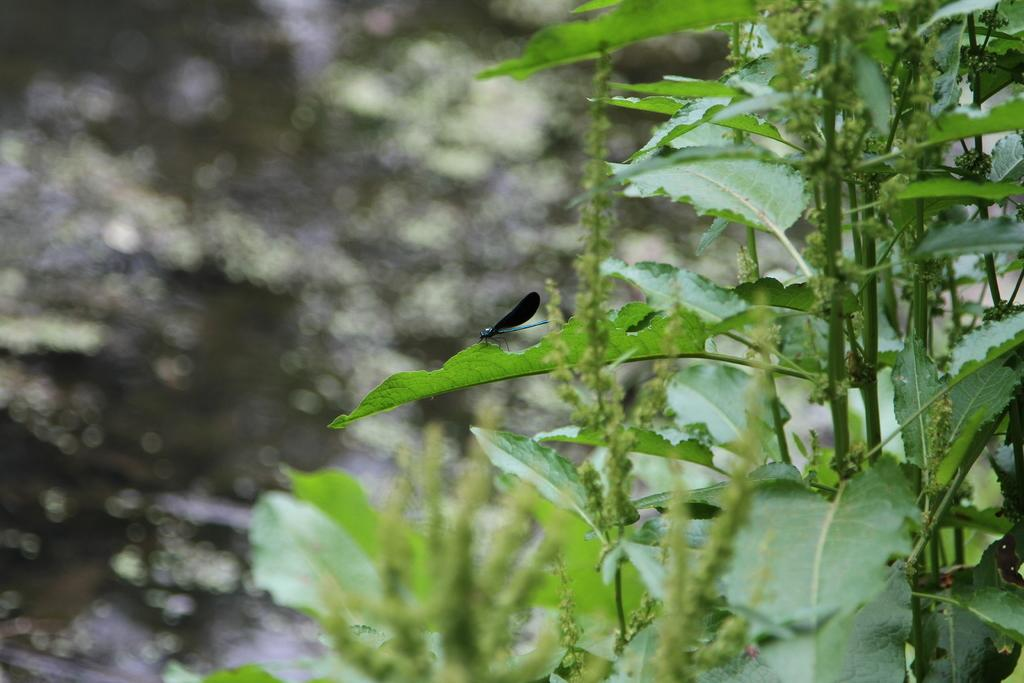What is located on the leaf in the image? There is an insect on a leaf in the image. What type of living organisms can be seen in the image? In addition to the insect, there are plants visible in the image. What type of game is being played on the leaf in the image? There is no game being played in the image; it features an insect on a leaf and plants. 